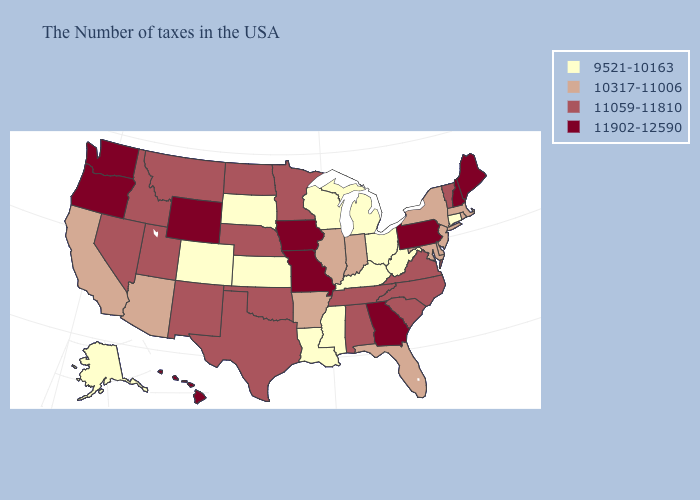What is the value of Utah?
Give a very brief answer. 11059-11810. What is the value of Nevada?
Keep it brief. 11059-11810. Does the map have missing data?
Be succinct. No. Does South Dakota have the lowest value in the MidWest?
Be succinct. Yes. What is the value of California?
Answer briefly. 10317-11006. Which states have the highest value in the USA?
Concise answer only. Maine, New Hampshire, Pennsylvania, Georgia, Missouri, Iowa, Wyoming, Washington, Oregon, Hawaii. Among the states that border Pennsylvania , which have the highest value?
Answer briefly. New York, New Jersey, Delaware, Maryland. Does Colorado have the same value as Delaware?
Be succinct. No. Name the states that have a value in the range 10317-11006?
Give a very brief answer. Massachusetts, Rhode Island, New York, New Jersey, Delaware, Maryland, Florida, Indiana, Illinois, Arkansas, Arizona, California. Among the states that border Colorado , does Kansas have the lowest value?
Give a very brief answer. Yes. Does the first symbol in the legend represent the smallest category?
Short answer required. Yes. Name the states that have a value in the range 11902-12590?
Concise answer only. Maine, New Hampshire, Pennsylvania, Georgia, Missouri, Iowa, Wyoming, Washington, Oregon, Hawaii. Name the states that have a value in the range 10317-11006?
Short answer required. Massachusetts, Rhode Island, New York, New Jersey, Delaware, Maryland, Florida, Indiana, Illinois, Arkansas, Arizona, California. Name the states that have a value in the range 11902-12590?
Short answer required. Maine, New Hampshire, Pennsylvania, Georgia, Missouri, Iowa, Wyoming, Washington, Oregon, Hawaii. 